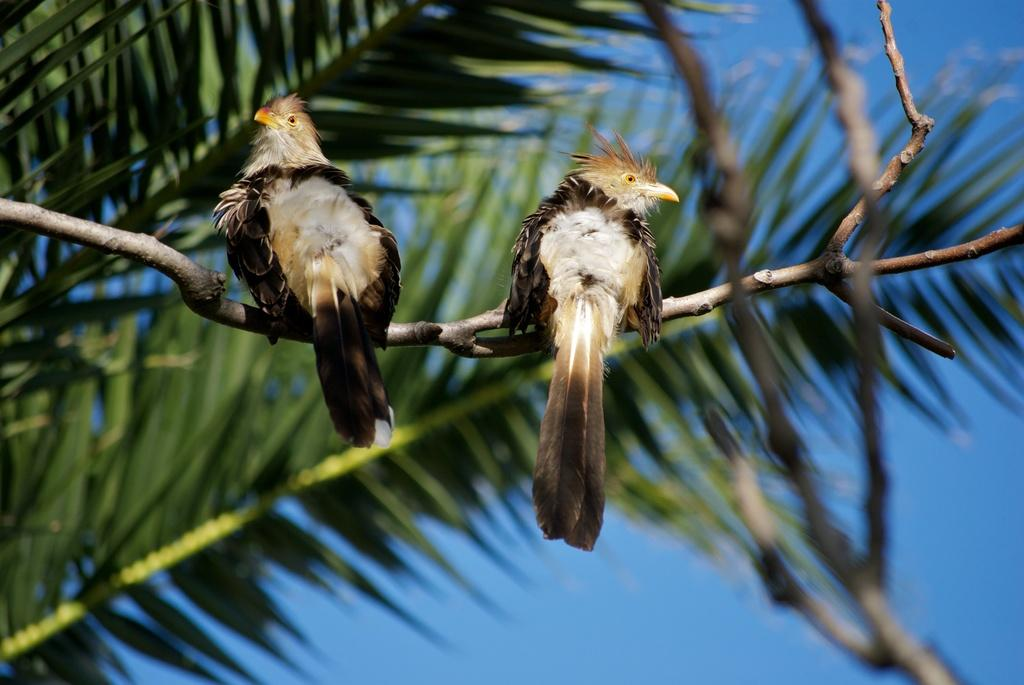How many birds are in the image? There are two birds in the image. Where are the birds located? The birds are on a branch. What can be seen in the background of the image? Trees and the sky are visible in the background of the image. What type of cork can be seen in the image? There is no cork present in the image. How does the bird's nose look in the image? Birds do not have noses like humans, and there is no specific focus on the bird's facial features in the image. 